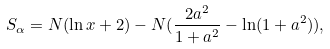Convert formula to latex. <formula><loc_0><loc_0><loc_500><loc_500>S _ { \alpha } = N ( \ln x + 2 ) - N ( \frac { 2 a ^ { 2 } } { 1 + a ^ { 2 } } - \ln ( 1 + a ^ { 2 } ) ) ,</formula> 